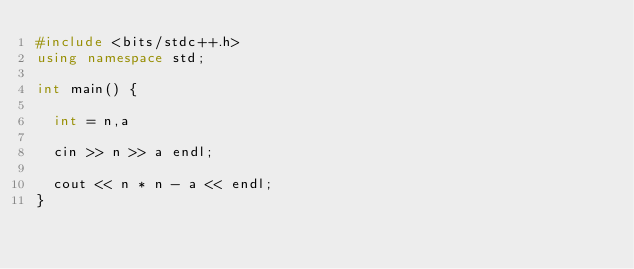Convert code to text. <code><loc_0><loc_0><loc_500><loc_500><_C++_>#include <bits/stdc++.h>
using namespace std;

int main() {
  
  int = n,a
  
  cin >> n >> a endl;
  
  cout << n * n - a << endl;
}
</code> 